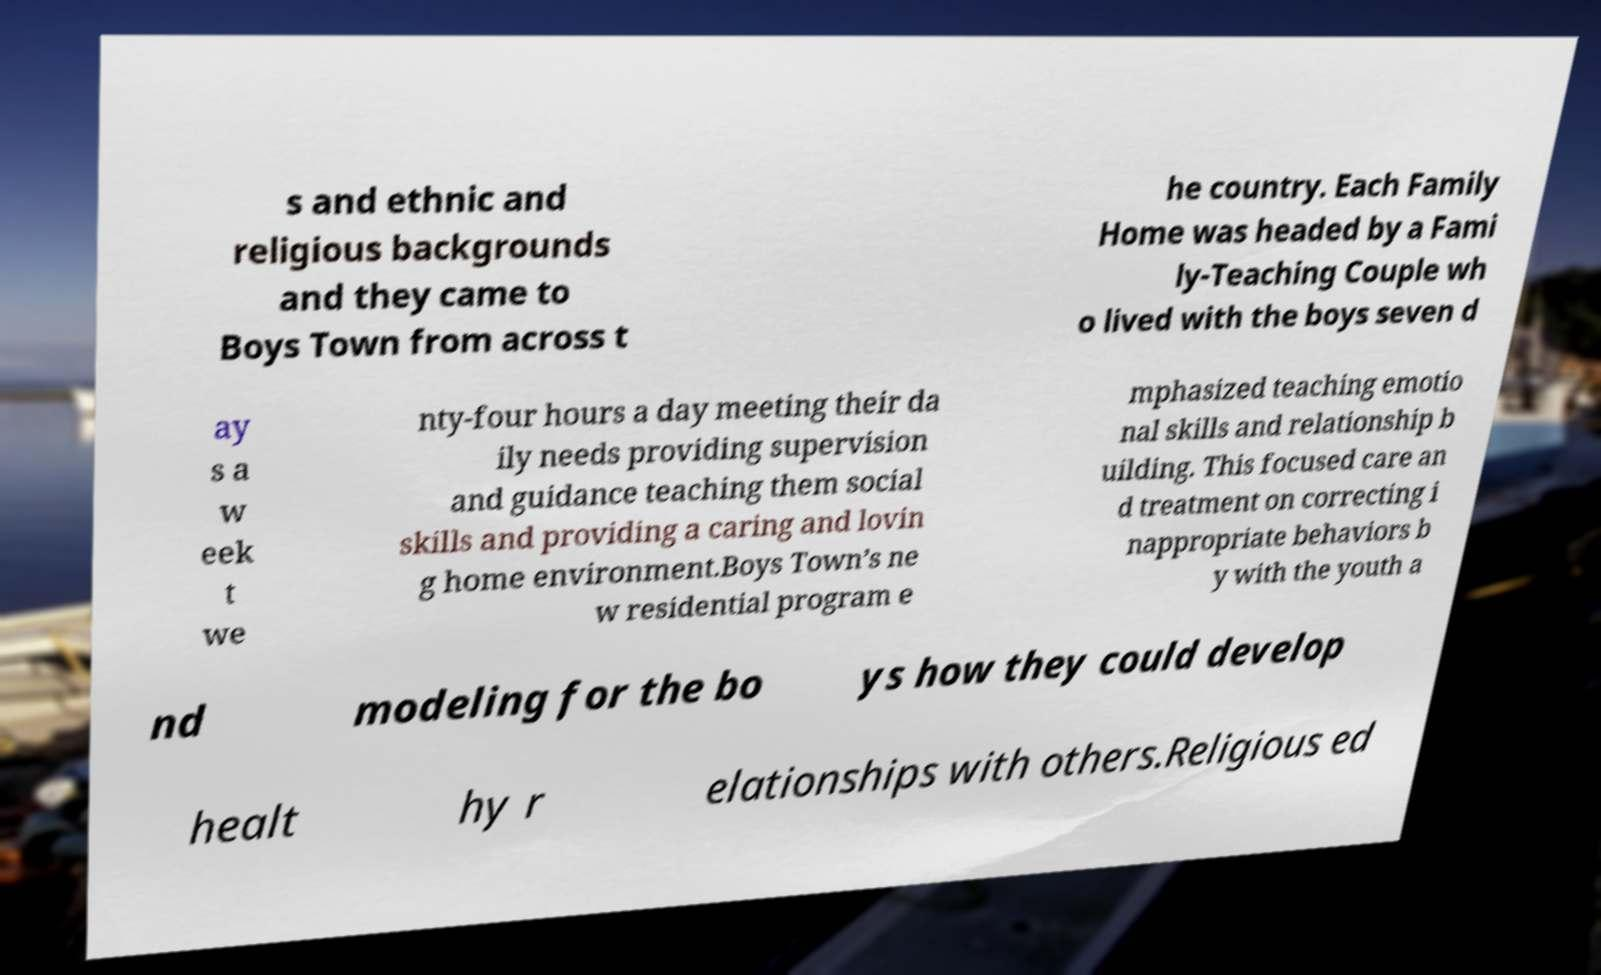Could you assist in decoding the text presented in this image and type it out clearly? s and ethnic and religious backgrounds and they came to Boys Town from across t he country. Each Family Home was headed by a Fami ly-Teaching Couple wh o lived with the boys seven d ay s a w eek t we nty-four hours a day meeting their da ily needs providing supervision and guidance teaching them social skills and providing a caring and lovin g home environment.Boys Town’s ne w residential program e mphasized teaching emotio nal skills and relationship b uilding. This focused care an d treatment on correcting i nappropriate behaviors b y with the youth a nd modeling for the bo ys how they could develop healt hy r elationships with others.Religious ed 